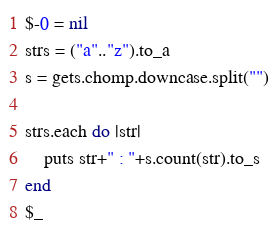<code> <loc_0><loc_0><loc_500><loc_500><_Ruby_>$-0 = nil
strs = ("a".."z").to_a
s = gets.chomp.downcase.split("")

strs.each do |str|
    puts str+" : "+s.count(str).to_s
end
$_
</code> 